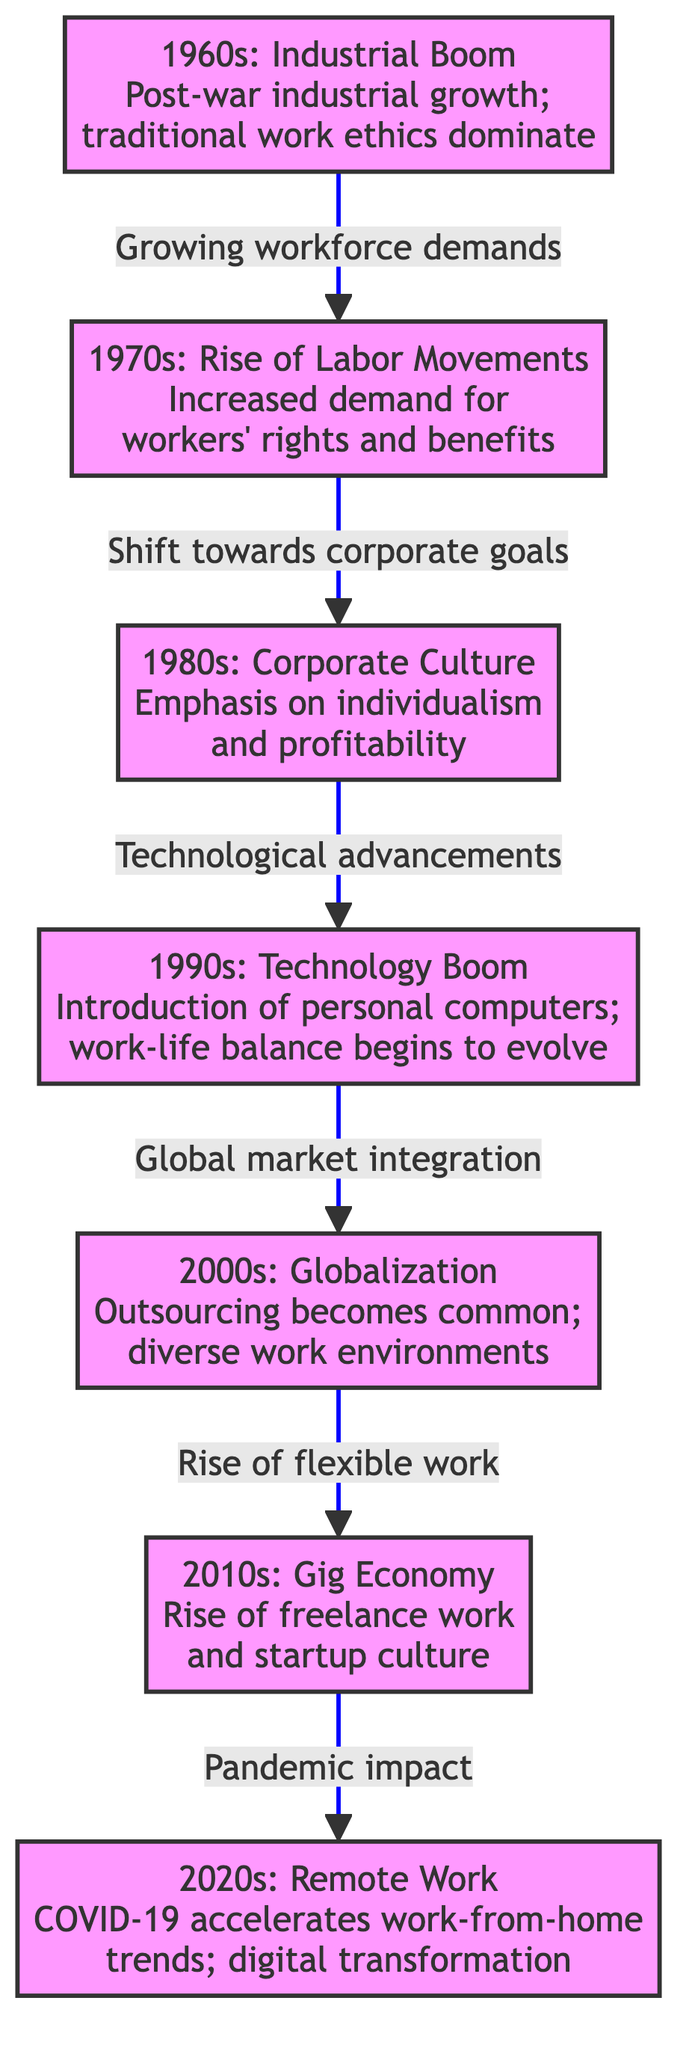What was the dominant work ethic in the 1960s? The diagram states that during the 1960s, traditional work ethics dominated due to post-war industrial growth, which indicates a strong adherence to established norms and practices in the workforce.
Answer: traditional work ethics Which decade saw the rise of the gig economy? The diagram specifies that the 2010s marked the rise of freelance work and startup culture, indicating a shift in work structure that is characteristic of the gig economy.
Answer: 2010s How many significant cultural shifts are noted in the timeline? By counting each decade represented in the diagram, there are seven significant cultural shifts from the 1960s to the 2020s, corresponding to the seven decades shown.
Answer: 7 What led to the shift from the 1990s to the 2000s? The transition from the 1990s to the 2000s is attributed to global market integration, indicating the conjunction of economic factors that accelerated working methods during that time.
Answer: Global market integration What event accelerated the remote work trend in the 2020s? According to the diagram, the COVID-19 pandemic was the significant event that accelerated the trend towards remote work in the 2020s, highlighting its impact on workplace dynamics.
Answer: COVID-19 What was a defining characteristic of the 1980s corporate culture? The diagram highlights that the 1980s corporate culture emphasized individualism and profitability, showcasing a significant change in values within the workplace during that period.
Answer: individualism and profitability Which decade represented the introduction of personal computers? The diagram specifies that the 1990s marked the introduction of personal computers in the workplace, which began to change how people worked and organized their tasks.
Answer: 1990s Which direction of work evolution follows the increased demand for workers' rights? The flow in the diagram indicates that following the increased demand for workers' rights in the 1970s, there was a subsequent shift towards corporate goals in the 1980s, connecting these two shifts in the evolution of work ethics.
Answer: corporate goals What is the primary trend of the 2000s in work environments? The primary trend identified for the 2000s is globalization, as outsourcing became common and diverse work environments emerged, indicating a restructuring of the workforce on a global scale.
Answer: globalization 